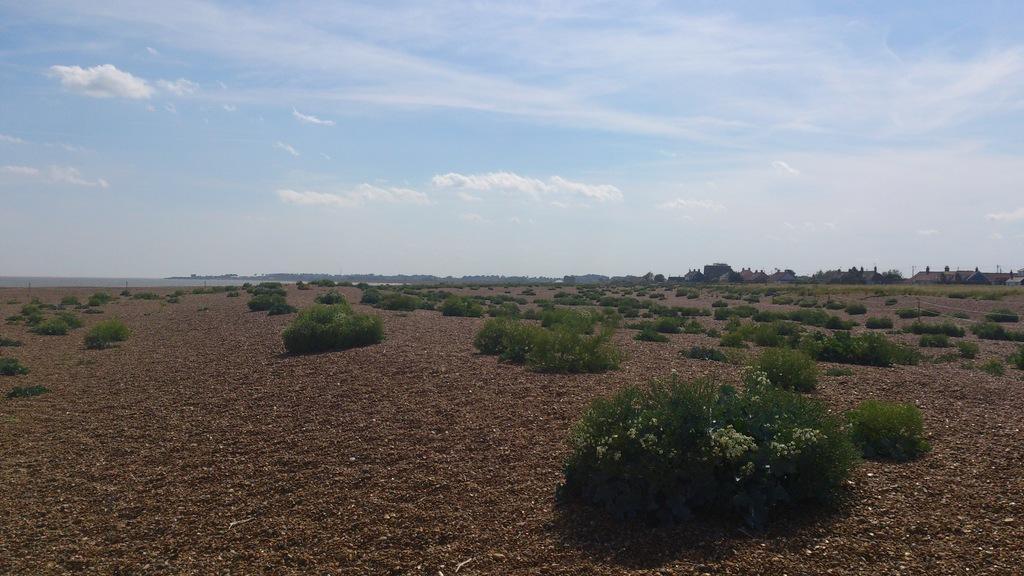Could you give a brief overview of what you see in this image? In this picture I can see there are few plants here and there is soil on the floor and in the backdrop there are buildings and trees and the sky is clear. 